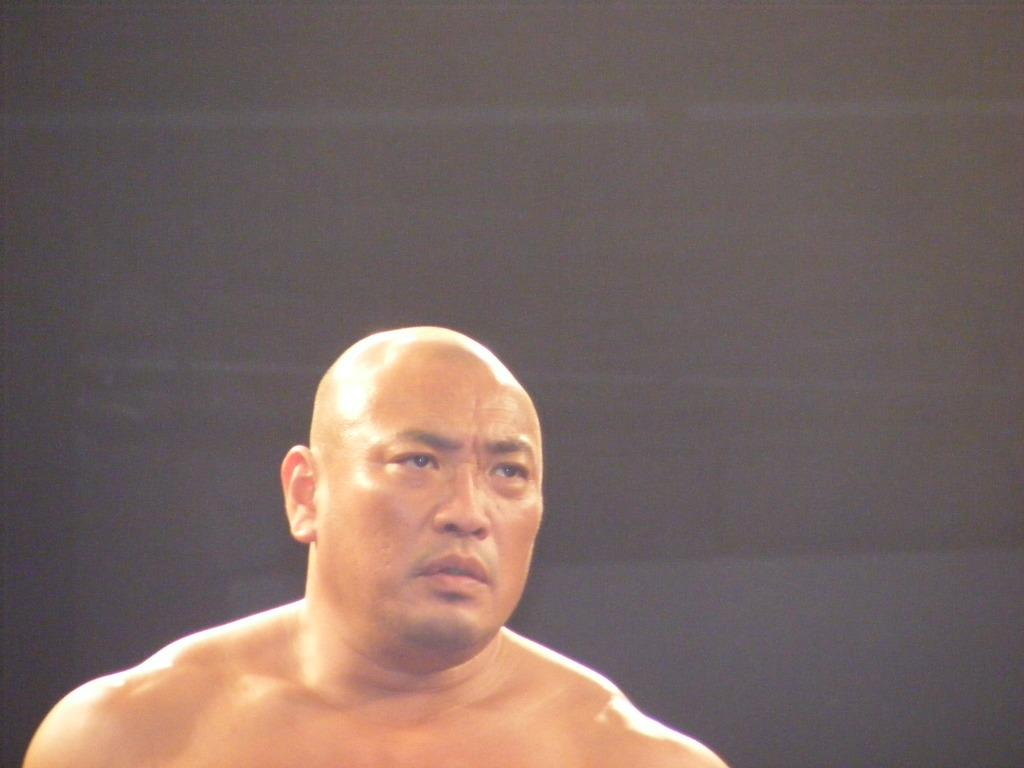What is the main subject of the image? The main subject of the image is a man. Can you describe the man's appearance? The man has a bald head. What can be seen in the background of the image? The background of the image is dark. What type of fire can be seen in the image? There is no fire present in the image. How old is the boy in the image? There is no boy present in the image. 